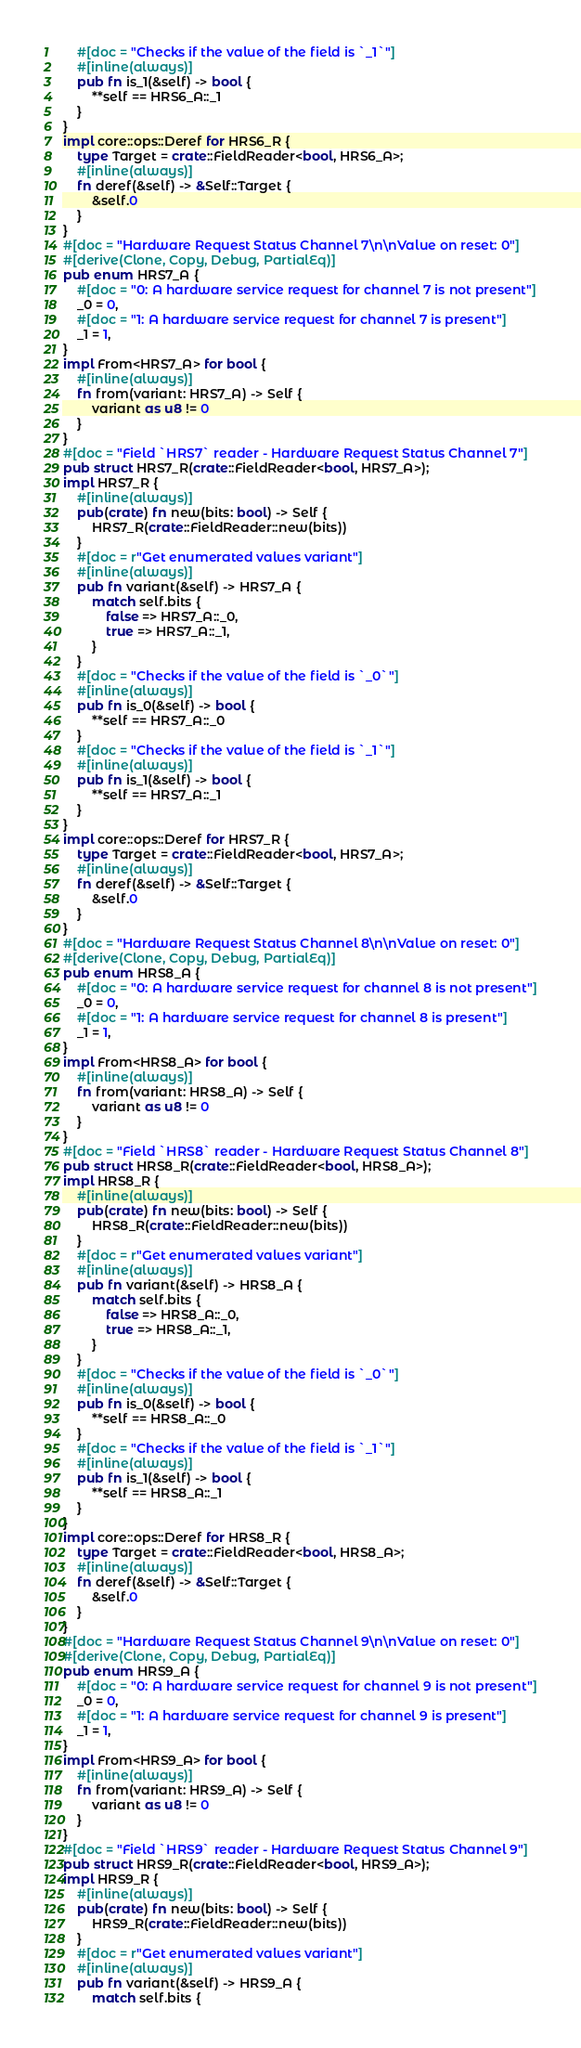<code> <loc_0><loc_0><loc_500><loc_500><_Rust_>    #[doc = "Checks if the value of the field is `_1`"]
    #[inline(always)]
    pub fn is_1(&self) -> bool {
        **self == HRS6_A::_1
    }
}
impl core::ops::Deref for HRS6_R {
    type Target = crate::FieldReader<bool, HRS6_A>;
    #[inline(always)]
    fn deref(&self) -> &Self::Target {
        &self.0
    }
}
#[doc = "Hardware Request Status Channel 7\n\nValue on reset: 0"]
#[derive(Clone, Copy, Debug, PartialEq)]
pub enum HRS7_A {
    #[doc = "0: A hardware service request for channel 7 is not present"]
    _0 = 0,
    #[doc = "1: A hardware service request for channel 7 is present"]
    _1 = 1,
}
impl From<HRS7_A> for bool {
    #[inline(always)]
    fn from(variant: HRS7_A) -> Self {
        variant as u8 != 0
    }
}
#[doc = "Field `HRS7` reader - Hardware Request Status Channel 7"]
pub struct HRS7_R(crate::FieldReader<bool, HRS7_A>);
impl HRS7_R {
    #[inline(always)]
    pub(crate) fn new(bits: bool) -> Self {
        HRS7_R(crate::FieldReader::new(bits))
    }
    #[doc = r"Get enumerated values variant"]
    #[inline(always)]
    pub fn variant(&self) -> HRS7_A {
        match self.bits {
            false => HRS7_A::_0,
            true => HRS7_A::_1,
        }
    }
    #[doc = "Checks if the value of the field is `_0`"]
    #[inline(always)]
    pub fn is_0(&self) -> bool {
        **self == HRS7_A::_0
    }
    #[doc = "Checks if the value of the field is `_1`"]
    #[inline(always)]
    pub fn is_1(&self) -> bool {
        **self == HRS7_A::_1
    }
}
impl core::ops::Deref for HRS7_R {
    type Target = crate::FieldReader<bool, HRS7_A>;
    #[inline(always)]
    fn deref(&self) -> &Self::Target {
        &self.0
    }
}
#[doc = "Hardware Request Status Channel 8\n\nValue on reset: 0"]
#[derive(Clone, Copy, Debug, PartialEq)]
pub enum HRS8_A {
    #[doc = "0: A hardware service request for channel 8 is not present"]
    _0 = 0,
    #[doc = "1: A hardware service request for channel 8 is present"]
    _1 = 1,
}
impl From<HRS8_A> for bool {
    #[inline(always)]
    fn from(variant: HRS8_A) -> Self {
        variant as u8 != 0
    }
}
#[doc = "Field `HRS8` reader - Hardware Request Status Channel 8"]
pub struct HRS8_R(crate::FieldReader<bool, HRS8_A>);
impl HRS8_R {
    #[inline(always)]
    pub(crate) fn new(bits: bool) -> Self {
        HRS8_R(crate::FieldReader::new(bits))
    }
    #[doc = r"Get enumerated values variant"]
    #[inline(always)]
    pub fn variant(&self) -> HRS8_A {
        match self.bits {
            false => HRS8_A::_0,
            true => HRS8_A::_1,
        }
    }
    #[doc = "Checks if the value of the field is `_0`"]
    #[inline(always)]
    pub fn is_0(&self) -> bool {
        **self == HRS8_A::_0
    }
    #[doc = "Checks if the value of the field is `_1`"]
    #[inline(always)]
    pub fn is_1(&self) -> bool {
        **self == HRS8_A::_1
    }
}
impl core::ops::Deref for HRS8_R {
    type Target = crate::FieldReader<bool, HRS8_A>;
    #[inline(always)]
    fn deref(&self) -> &Self::Target {
        &self.0
    }
}
#[doc = "Hardware Request Status Channel 9\n\nValue on reset: 0"]
#[derive(Clone, Copy, Debug, PartialEq)]
pub enum HRS9_A {
    #[doc = "0: A hardware service request for channel 9 is not present"]
    _0 = 0,
    #[doc = "1: A hardware service request for channel 9 is present"]
    _1 = 1,
}
impl From<HRS9_A> for bool {
    #[inline(always)]
    fn from(variant: HRS9_A) -> Self {
        variant as u8 != 0
    }
}
#[doc = "Field `HRS9` reader - Hardware Request Status Channel 9"]
pub struct HRS9_R(crate::FieldReader<bool, HRS9_A>);
impl HRS9_R {
    #[inline(always)]
    pub(crate) fn new(bits: bool) -> Self {
        HRS9_R(crate::FieldReader::new(bits))
    }
    #[doc = r"Get enumerated values variant"]
    #[inline(always)]
    pub fn variant(&self) -> HRS9_A {
        match self.bits {</code> 